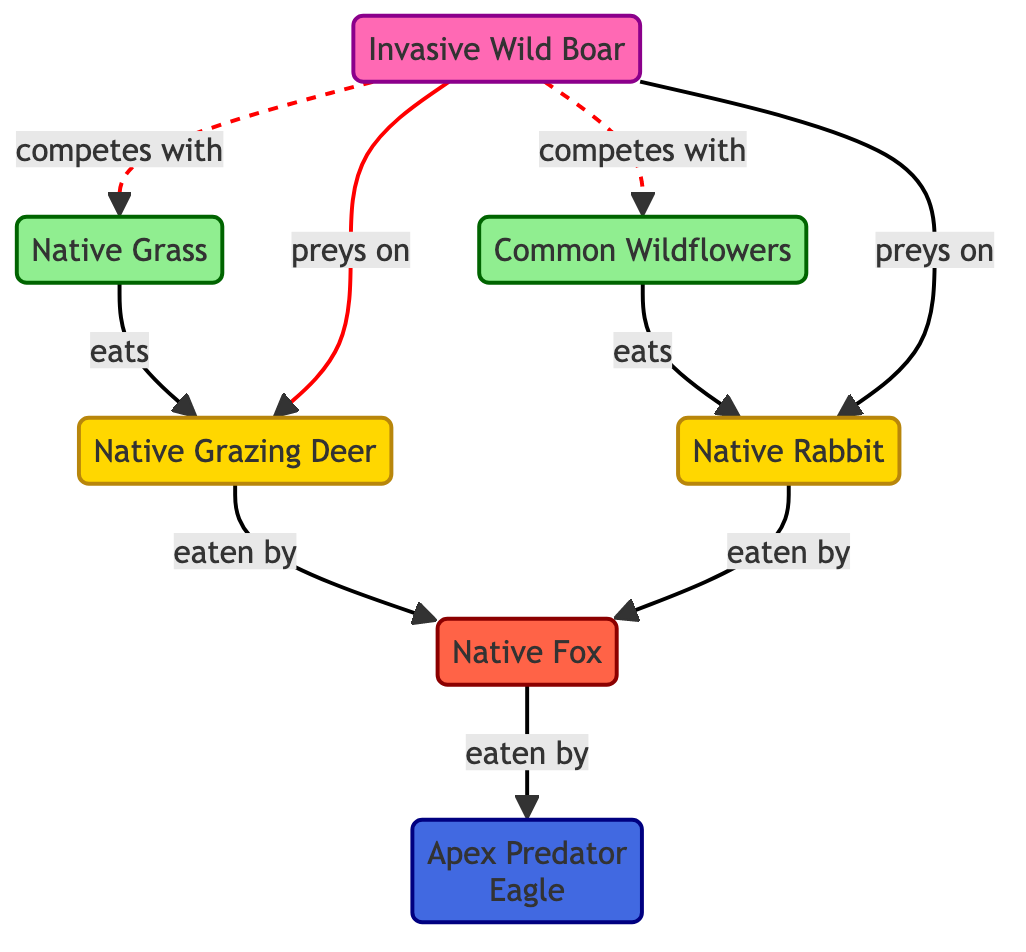What are the two native plant species in the food chain? The diagram shows two nodes representing native plant species: Native Grass and Common Wildflowers. These are explicitly labeled in the diagram.
Answer: Native Grass, Common Wildflowers How many herbivores are present in the diagram? There are two nodes labeled as herbivores: Native Grazing Deer and Native Rabbit, hence there are two herbivores in total.
Answer: 2 Which species preys on the native grazing deer? The diagram indicates that the invasive species, Invasive Wild Boar, preys on the Native Grazing Deer. This relationship is shown by a directed link.
Answer: Invasive Wild Boar What effect does the invasive wild boar have on native plants? The invasive wild boar competes with both Native Grass and Common Wildflowers as indicated by the dashed lines representing competition in the diagram.
Answer: Competes with native plants What is the apex predator in this food chain? Apex predator is directly labeled in the diagram as "Apex Predator Eagle," making it clear that this species occupies the highest trophic level.
Answer: Apex Predator Eagle How does the introduction of the invasive species affect the predator's diet? The native fox, which preys on the native grazing deer and native rabbit, may face a decrease in prey availability due to the invasive wild boar feeding on these herbivores, thereby affecting its diet indirectly.
Answer: Decrease in native prey availability Which relationship is represented by a solid line? All feeding relationships in the food chain, such as the herbivores eating plants and predators eating herbivores, are depicted by solid lines, indicating direct trophic links.
Answer: Feeding relationships What type of connection is shown between invasive species and native plants? The connection between the invasive species and native plants is characterized as a competition for resources, displayed by dashed lines, indicating a non-trophic interaction.
Answer: Competition 